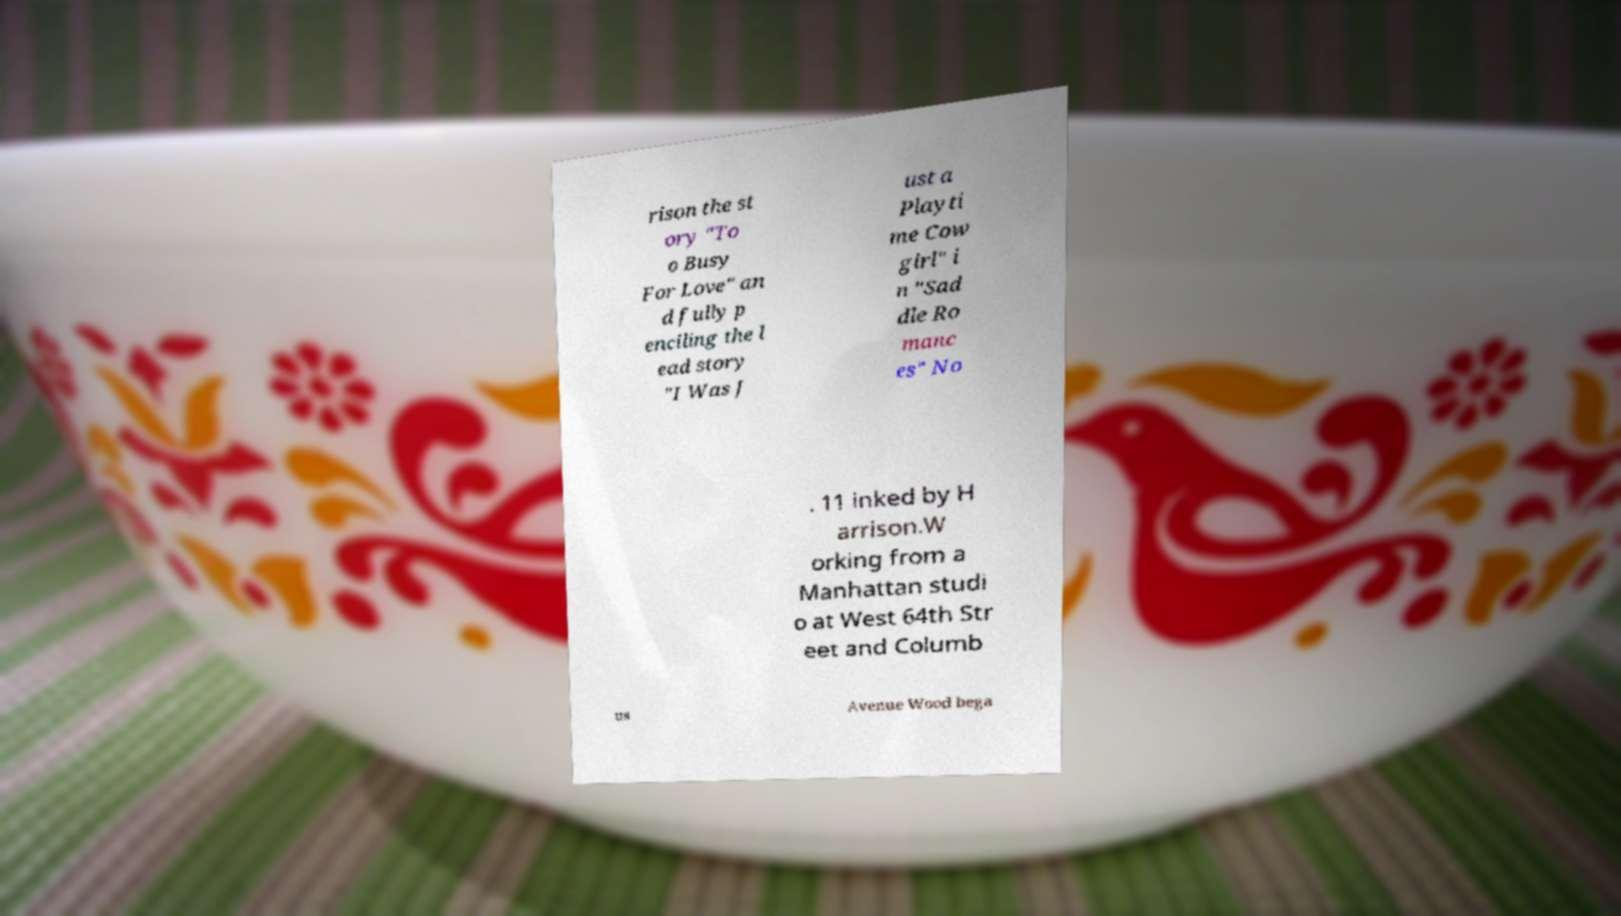Please identify and transcribe the text found in this image. rison the st ory "To o Busy For Love" an d fully p enciling the l ead story "I Was J ust a Playti me Cow girl" i n "Sad dle Ro manc es" No . 11 inked by H arrison.W orking from a Manhattan studi o at West 64th Str eet and Columb us Avenue Wood bega 